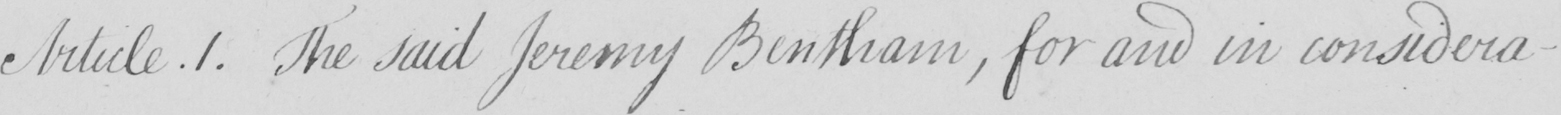What is written in this line of handwriting? The said Jeremy Bentham , for and in considera- 